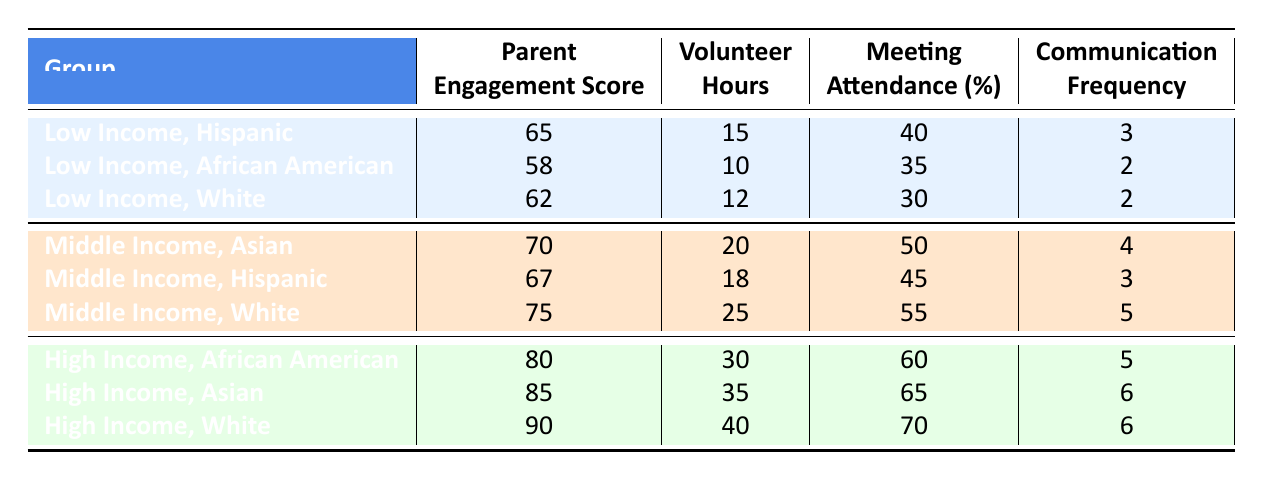What is the Parent Engagement Score for Low Income Hispanic parents? Referring to the table, the Parent Engagement Score for Low Income Hispanic parents is listed directly as 65.
Answer: 65 What is the total number of Volunteer Hours for Middle Income families in this table? We add the Volunteer Hours for Middle Income families: 20 (Asian) + 18 (Hispanic) + 25 (White) = 63.
Answer: 63 Which ethnic background has the highest Parent Engagement Score in the High Income category? Looking at the High Income category, the Parent Engagement Scores are: African American 80, Asian 85, and White 90. The highest score is from White parents at 90.
Answer: White Is the average Meeting Attendance percentage for Low Income families less than 40%? The Meeting Attendance percentages for Low Income families are 40 (Hispanic), 35 (African American), and 30 (White). Average = (40 + 35 + 30) / 3 = 35, which is less than 40%.
Answer: Yes What is the difference in Parent Engagement Scores between the highest and lowest scoring ethnic backgrounds in the Middle Income category? The Parent Engagement Scores for Middle Income are: Asian 70, Hispanic 67, and White 75. The highest is 75 (White) and the lowest is 67 (Hispanic). The difference is 75 - 67 = 8.
Answer: 8 Which group has the least Communication Frequency among all groups presented? The Communication Frequencies are: Low Income Hispanic 3, Low Income African American 2, Low Income White 2, Middle Income Asian 4, Middle Income Hispanic 3, Middle Income White 5, High Income African American 5, High Income Asian 6, High Income White 6. The lowest frequencies of 2 are for Low Income African American and Low Income White.
Answer: Low Income African American and Low Income White How does the overall trend in Parent Engagement Scores differ between socioeconomic statuses? Comparing the averages reveals: Low Income average = (65 + 58 + 62) / 3 = 61.67, Middle Income average = (70 + 67 + 75) / 3 = 70.67, High Income average = (80 + 85 + 90) / 3 = 85. Therefore, the trend shows increasing engagement scores from Low to Middle to High Income categories.
Answer: Increases from Low to High Income 